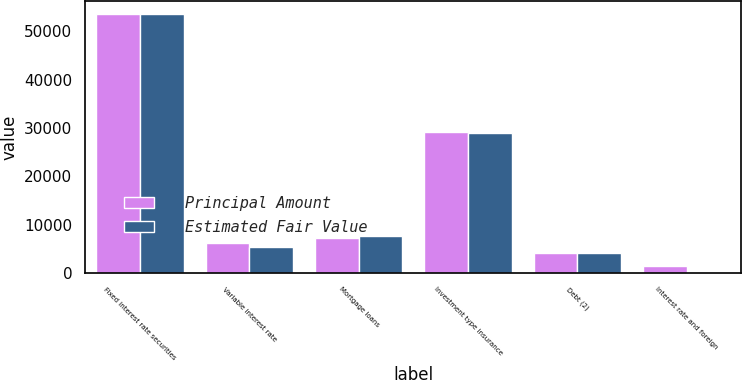Convert chart to OTSL. <chart><loc_0><loc_0><loc_500><loc_500><stacked_bar_chart><ecel><fcel>Fixed interest rate securities<fcel>Variable interest rate<fcel>Mortgage loans<fcel>Investment type insurance<fcel>Debt (2)<fcel>Interest rate and foreign<nl><fcel>Principal Amount<fcel>53512<fcel>6215<fcel>7313<fcel>29107<fcel>4106<fcel>1374<nl><fcel>Estimated Fair Value<fcel>53530<fcel>5358<fcel>7570<fcel>28939<fcel>4219<fcel>1<nl></chart> 